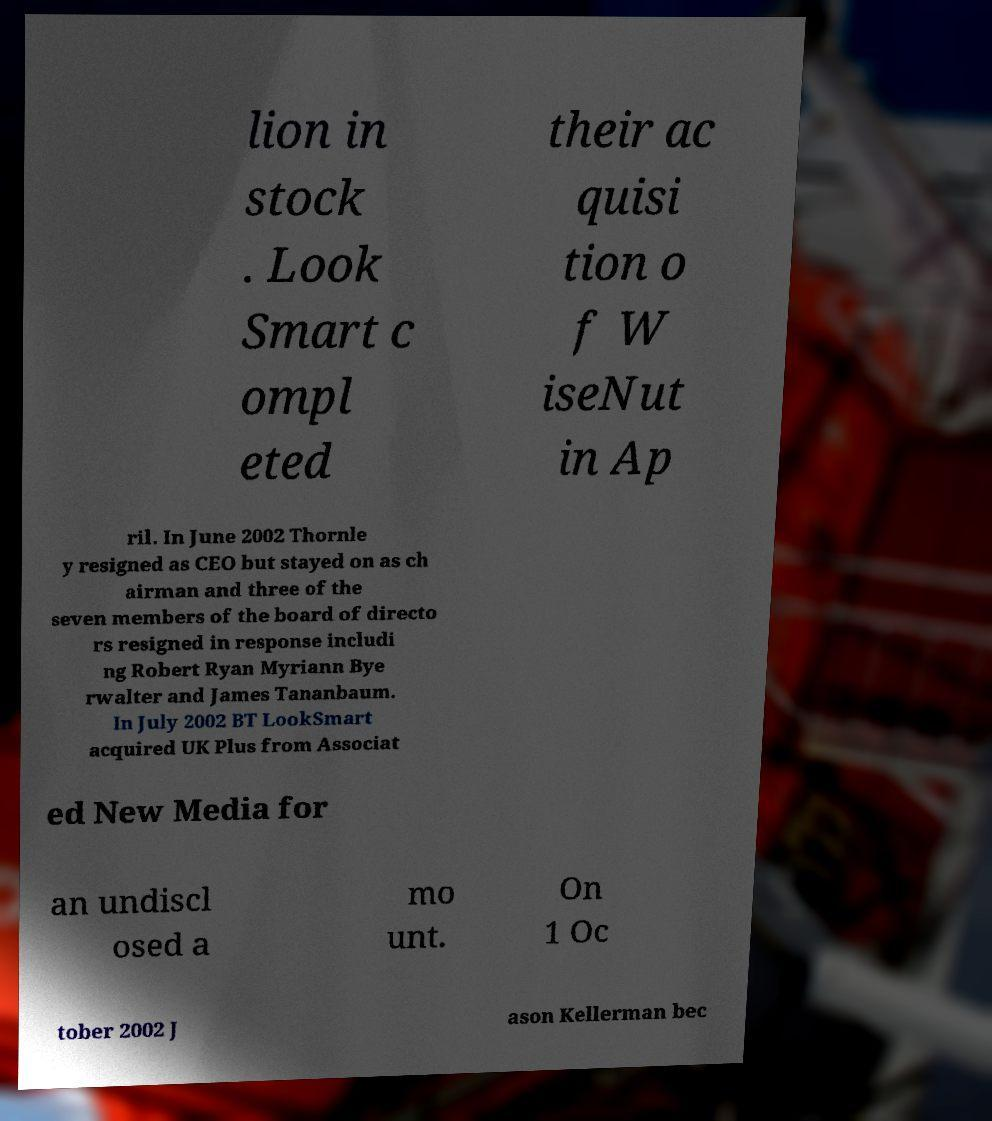Could you assist in decoding the text presented in this image and type it out clearly? lion in stock . Look Smart c ompl eted their ac quisi tion o f W iseNut in Ap ril. In June 2002 Thornle y resigned as CEO but stayed on as ch airman and three of the seven members of the board of directo rs resigned in response includi ng Robert Ryan Myriann Bye rwalter and James Tananbaum. In July 2002 BT LookSmart acquired UK Plus from Associat ed New Media for an undiscl osed a mo unt. On 1 Oc tober 2002 J ason Kellerman bec 